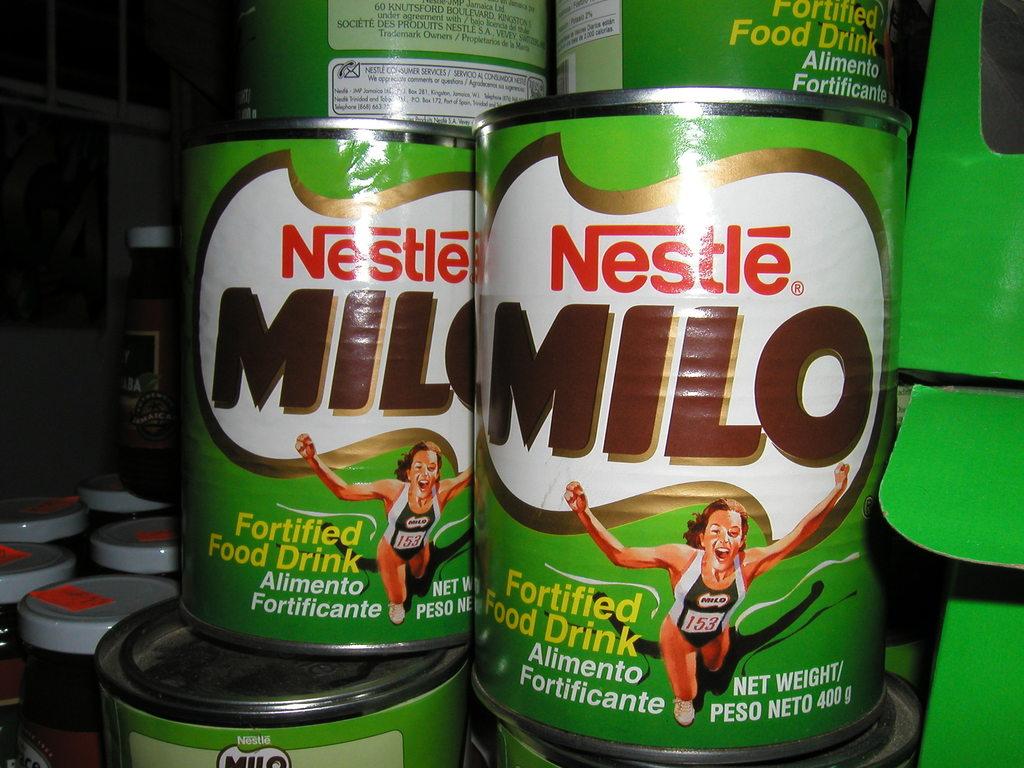Who makes milo?
Ensure brevity in your answer.  Nestle. How many grams are there in a can?
Offer a terse response. 400. 